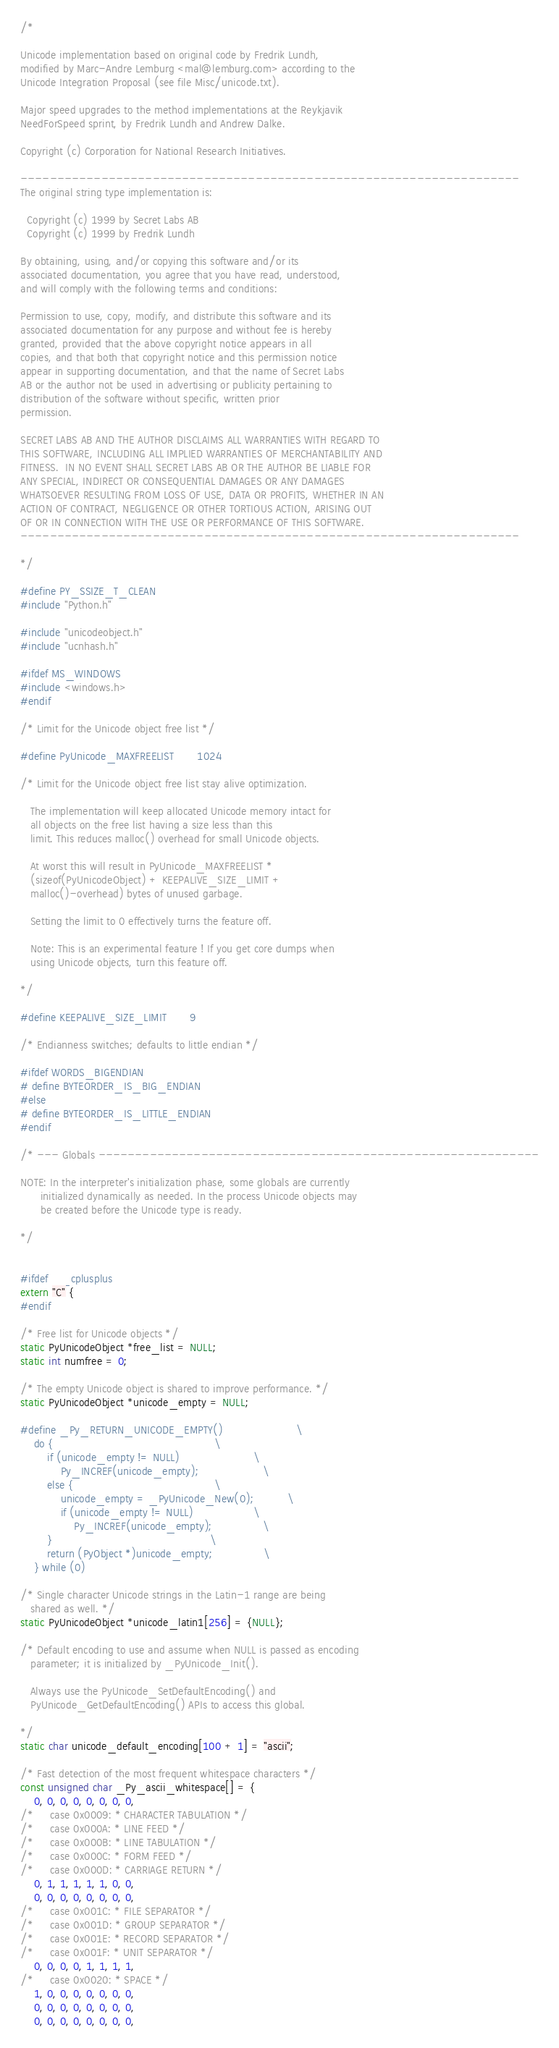Convert code to text. <code><loc_0><loc_0><loc_500><loc_500><_C_>/*

Unicode implementation based on original code by Fredrik Lundh,
modified by Marc-Andre Lemburg <mal@lemburg.com> according to the
Unicode Integration Proposal (see file Misc/unicode.txt).

Major speed upgrades to the method implementations at the Reykjavik
NeedForSpeed sprint, by Fredrik Lundh and Andrew Dalke.

Copyright (c) Corporation for National Research Initiatives.

--------------------------------------------------------------------
The original string type implementation is:

  Copyright (c) 1999 by Secret Labs AB
  Copyright (c) 1999 by Fredrik Lundh

By obtaining, using, and/or copying this software and/or its
associated documentation, you agree that you have read, understood,
and will comply with the following terms and conditions:

Permission to use, copy, modify, and distribute this software and its
associated documentation for any purpose and without fee is hereby
granted, provided that the above copyright notice appears in all
copies, and that both that copyright notice and this permission notice
appear in supporting documentation, and that the name of Secret Labs
AB or the author not be used in advertising or publicity pertaining to
distribution of the software without specific, written prior
permission.

SECRET LABS AB AND THE AUTHOR DISCLAIMS ALL WARRANTIES WITH REGARD TO
THIS SOFTWARE, INCLUDING ALL IMPLIED WARRANTIES OF MERCHANTABILITY AND
FITNESS.  IN NO EVENT SHALL SECRET LABS AB OR THE AUTHOR BE LIABLE FOR
ANY SPECIAL, INDIRECT OR CONSEQUENTIAL DAMAGES OR ANY DAMAGES
WHATSOEVER RESULTING FROM LOSS OF USE, DATA OR PROFITS, WHETHER IN AN
ACTION OF CONTRACT, NEGLIGENCE OR OTHER TORTIOUS ACTION, ARISING OUT
OF OR IN CONNECTION WITH THE USE OR PERFORMANCE OF THIS SOFTWARE.
--------------------------------------------------------------------

*/

#define PY_SSIZE_T_CLEAN
#include "Python.h"

#include "unicodeobject.h"
#include "ucnhash.h"

#ifdef MS_WINDOWS
#include <windows.h>
#endif

/* Limit for the Unicode object free list */

#define PyUnicode_MAXFREELIST       1024

/* Limit for the Unicode object free list stay alive optimization.

   The implementation will keep allocated Unicode memory intact for
   all objects on the free list having a size less than this
   limit. This reduces malloc() overhead for small Unicode objects.

   At worst this will result in PyUnicode_MAXFREELIST *
   (sizeof(PyUnicodeObject) + KEEPALIVE_SIZE_LIMIT +
   malloc()-overhead) bytes of unused garbage.

   Setting the limit to 0 effectively turns the feature off.

   Note: This is an experimental feature ! If you get core dumps when
   using Unicode objects, turn this feature off.

*/

#define KEEPALIVE_SIZE_LIMIT       9

/* Endianness switches; defaults to little endian */

#ifdef WORDS_BIGENDIAN
# define BYTEORDER_IS_BIG_ENDIAN
#else
# define BYTEORDER_IS_LITTLE_ENDIAN
#endif

/* --- Globals ------------------------------------------------------------

NOTE: In the interpreter's initialization phase, some globals are currently
      initialized dynamically as needed. In the process Unicode objects may
      be created before the Unicode type is ready.

*/


#ifdef __cplusplus
extern "C" {
#endif

/* Free list for Unicode objects */
static PyUnicodeObject *free_list = NULL;
static int numfree = 0;

/* The empty Unicode object is shared to improve performance. */
static PyUnicodeObject *unicode_empty = NULL;

#define _Py_RETURN_UNICODE_EMPTY()                      \
    do {                                                \
        if (unicode_empty != NULL)                      \
            Py_INCREF(unicode_empty);                   \
        else {                                          \
            unicode_empty = _PyUnicode_New(0);          \
            if (unicode_empty != NULL)                  \
                Py_INCREF(unicode_empty);               \
        }                                               \
        return (PyObject *)unicode_empty;               \
    } while (0)

/* Single character Unicode strings in the Latin-1 range are being
   shared as well. */
static PyUnicodeObject *unicode_latin1[256] = {NULL};

/* Default encoding to use and assume when NULL is passed as encoding
   parameter; it is initialized by _PyUnicode_Init().

   Always use the PyUnicode_SetDefaultEncoding() and
   PyUnicode_GetDefaultEncoding() APIs to access this global.

*/
static char unicode_default_encoding[100 + 1] = "ascii";

/* Fast detection of the most frequent whitespace characters */
const unsigned char _Py_ascii_whitespace[] = {
    0, 0, 0, 0, 0, 0, 0, 0,
/*     case 0x0009: * CHARACTER TABULATION */
/*     case 0x000A: * LINE FEED */
/*     case 0x000B: * LINE TABULATION */
/*     case 0x000C: * FORM FEED */
/*     case 0x000D: * CARRIAGE RETURN */
    0, 1, 1, 1, 1, 1, 0, 0,
    0, 0, 0, 0, 0, 0, 0, 0,
/*     case 0x001C: * FILE SEPARATOR */
/*     case 0x001D: * GROUP SEPARATOR */
/*     case 0x001E: * RECORD SEPARATOR */
/*     case 0x001F: * UNIT SEPARATOR */
    0, 0, 0, 0, 1, 1, 1, 1,
/*     case 0x0020: * SPACE */
    1, 0, 0, 0, 0, 0, 0, 0,
    0, 0, 0, 0, 0, 0, 0, 0,
    0, 0, 0, 0, 0, 0, 0, 0,</code> 